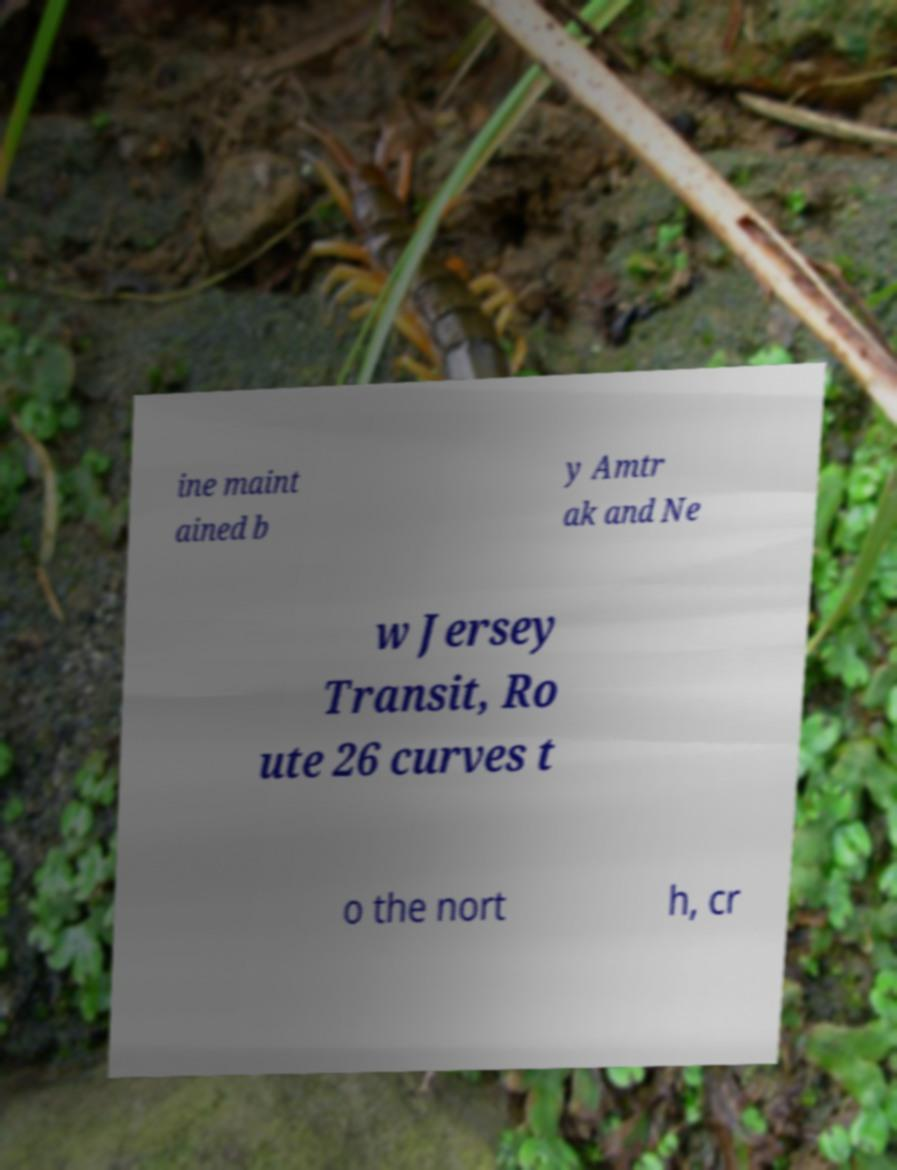There's text embedded in this image that I need extracted. Can you transcribe it verbatim? ine maint ained b y Amtr ak and Ne w Jersey Transit, Ro ute 26 curves t o the nort h, cr 